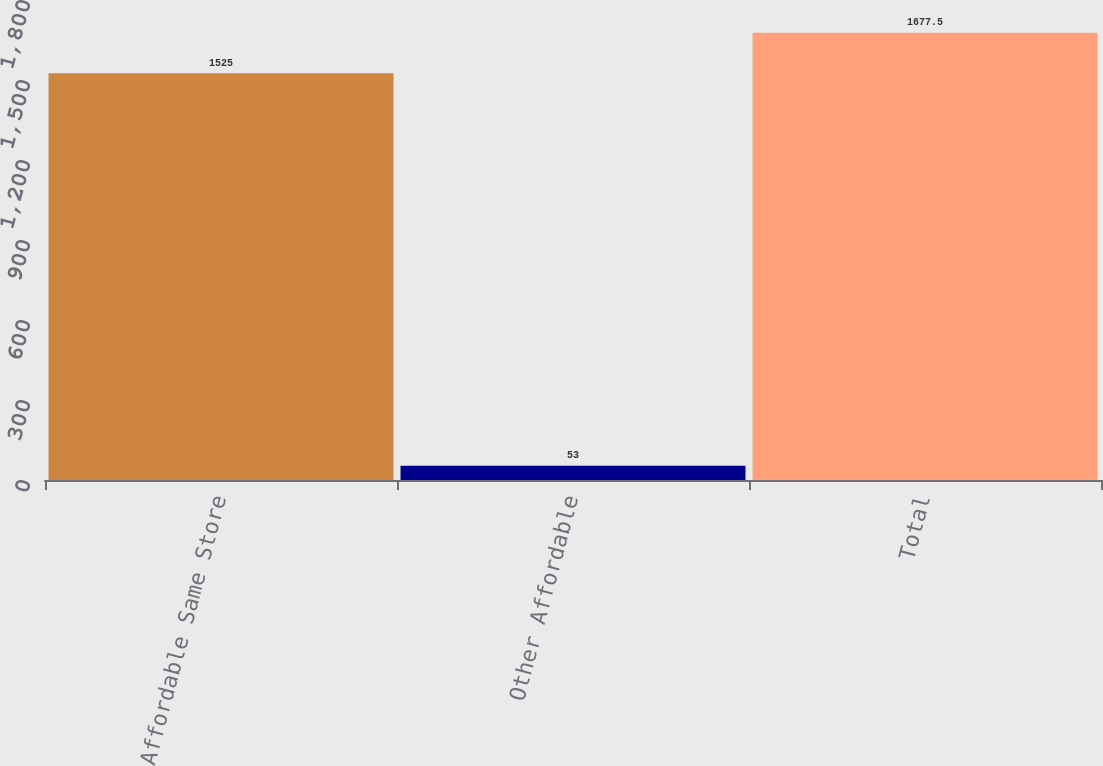Convert chart. <chart><loc_0><loc_0><loc_500><loc_500><bar_chart><fcel>Affordable Same Store<fcel>Other Affordable<fcel>Total<nl><fcel>1525<fcel>53<fcel>1677.5<nl></chart> 